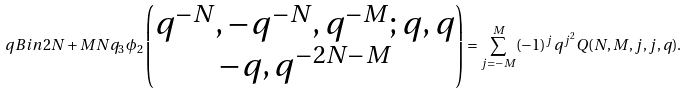Convert formula to latex. <formula><loc_0><loc_0><loc_500><loc_500>\ q B i n { 2 N + M } { N } { q } _ { 3 } \phi _ { 2 } \begin{pmatrix} q ^ { - N } , - q ^ { - N } , q ^ { - M } ; q , q \\ - q , q ^ { - 2 N - M } \end{pmatrix} = \sum _ { j = - M } ^ { M } ( - 1 ) ^ { j } q ^ { j ^ { 2 } } Q ( N , M , j , j , q ) .</formula> 